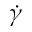<formula> <loc_0><loc_0><loc_500><loc_500>\dot { \gamma }</formula> 